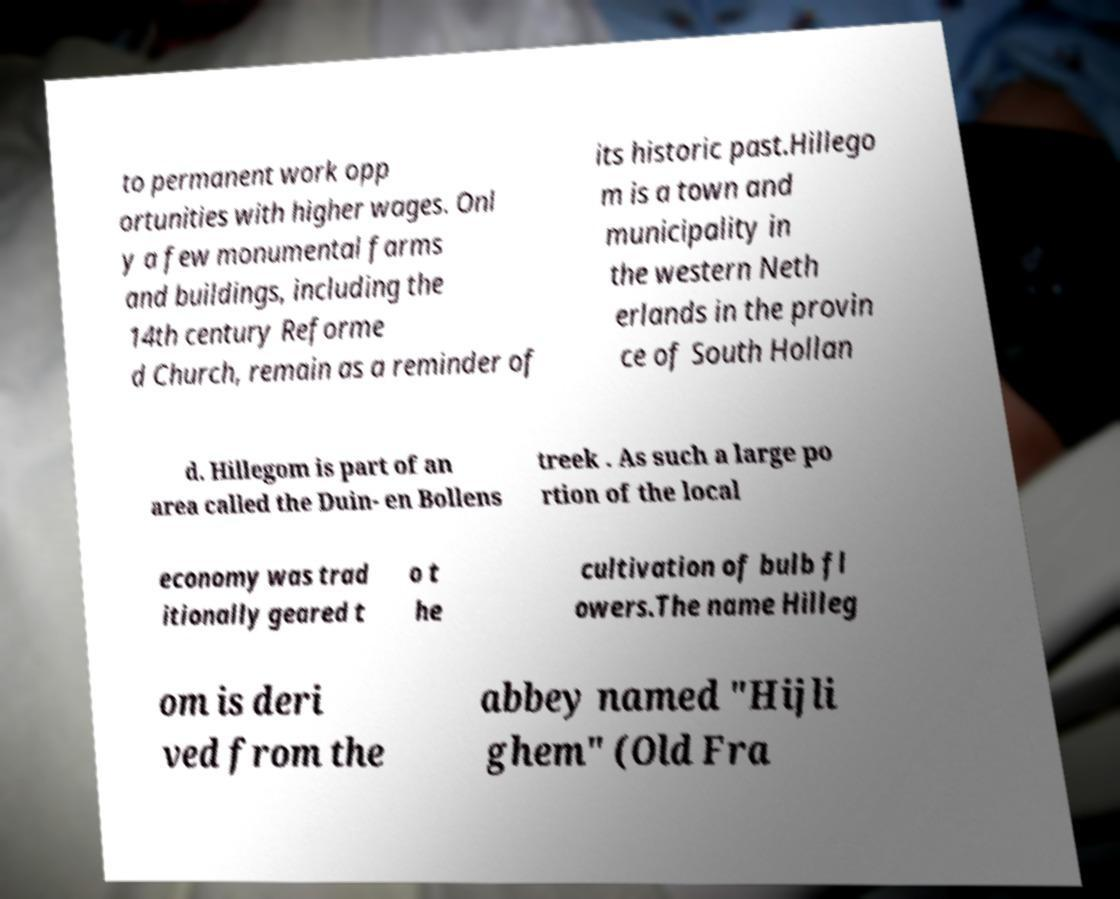What messages or text are displayed in this image? I need them in a readable, typed format. to permanent work opp ortunities with higher wages. Onl y a few monumental farms and buildings, including the 14th century Reforme d Church, remain as a reminder of its historic past.Hillego m is a town and municipality in the western Neth erlands in the provin ce of South Hollan d. Hillegom is part of an area called the Duin- en Bollens treek . As such a large po rtion of the local economy was trad itionally geared t o t he cultivation of bulb fl owers.The name Hilleg om is deri ved from the abbey named "Hijli ghem" (Old Fra 